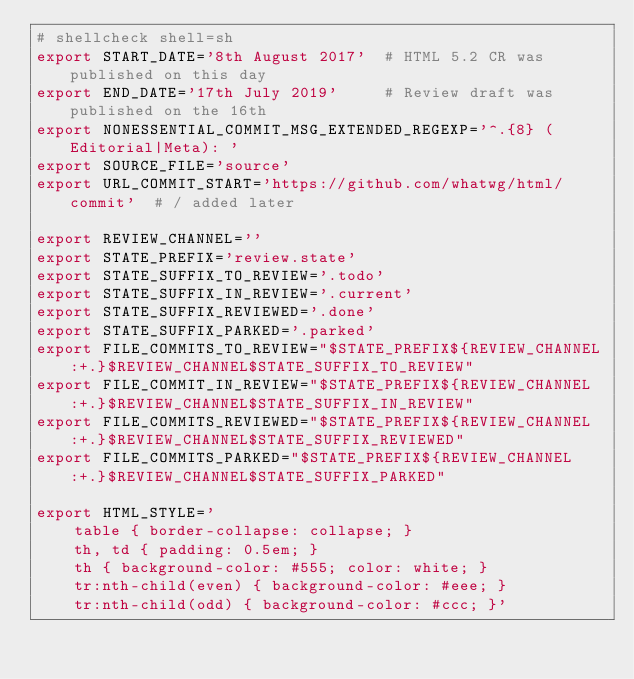Convert code to text. <code><loc_0><loc_0><loc_500><loc_500><_Bash_># shellcheck shell=sh
export START_DATE='8th August 2017'  # HTML 5.2 CR was published on this day
export END_DATE='17th July 2019'     # Review draft was published on the 16th
export NONESSENTIAL_COMMIT_MSG_EXTENDED_REGEXP='^.{8} (Editorial|Meta): '
export SOURCE_FILE='source'
export URL_COMMIT_START='https://github.com/whatwg/html/commit'  # / added later

export REVIEW_CHANNEL=''
export STATE_PREFIX='review.state'
export STATE_SUFFIX_TO_REVIEW='.todo'
export STATE_SUFFIX_IN_REVIEW='.current'
export STATE_SUFFIX_REVIEWED='.done'
export STATE_SUFFIX_PARKED='.parked'
export FILE_COMMITS_TO_REVIEW="$STATE_PREFIX${REVIEW_CHANNEL:+.}$REVIEW_CHANNEL$STATE_SUFFIX_TO_REVIEW"
export FILE_COMMIT_IN_REVIEW="$STATE_PREFIX${REVIEW_CHANNEL:+.}$REVIEW_CHANNEL$STATE_SUFFIX_IN_REVIEW"
export FILE_COMMITS_REVIEWED="$STATE_PREFIX${REVIEW_CHANNEL:+.}$REVIEW_CHANNEL$STATE_SUFFIX_REVIEWED"
export FILE_COMMITS_PARKED="$STATE_PREFIX${REVIEW_CHANNEL:+.}$REVIEW_CHANNEL$STATE_SUFFIX_PARKED"

export HTML_STYLE='
	table { border-collapse: collapse; }
	th, td { padding: 0.5em; }
	th { background-color: #555; color: white; }
	tr:nth-child(even) { background-color: #eee; }
	tr:nth-child(odd) { background-color: #ccc; }'
</code> 